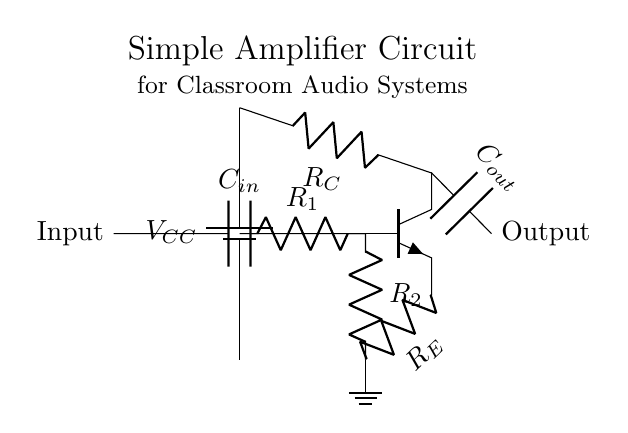What is the type of transistor used in this circuit? The circuit depicts an NPN transistor, as indicated by the npn notation next to the transistor symbol.
Answer: NPN What component controls the output voltage? The component that affects the output voltage in the circuit is the capacitor connected to the collector of the transistor, which smooths the output signal.
Answer: Capacitor What is the function of resistor R2? Resistor R2, connected between the base of the transistor and ground, helps set the biasing for the transistor, ensuring it operates in the active region for amplification.
Answer: Biasing Which components provide input and output filtering in this amplifier? The capacitors labeled C_in on the input side and C_out on the output side function as coupling capacitors, allowing the desired AC signals to pass while blocking DC components.
Answer: Capacitors What is the ground reference in this circuit? The ground reference is represented by the node directly connected to the emitter of the transistor at the bottom, which serves as the zero voltage level for the circuit.
Answer: Emitter Node How does this amplifier increase the input signal? The amplifier increases the input signal by using the voltage gain provided by the transistor. The ratio of the resistors R_C and R_E determines the gain, amplifying the input voltage to produce a larger output voltage.
Answer: Voltage Gain 